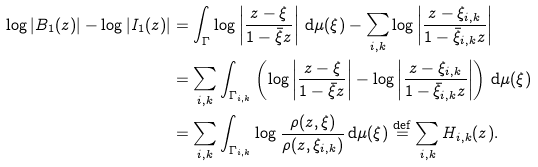<formula> <loc_0><loc_0><loc_500><loc_500>\log | B _ { 1 } ( z ) | - \log | I _ { 1 } ( z ) | & = \int _ { \Gamma } \log \left | \frac { z - \xi } { 1 - \bar { \xi } z } \right | \, \mathrm d \mu ( \xi ) - \sum _ { i , k } \log \left | \frac { z - \xi _ { i , k } } { 1 - \bar { \xi } _ { i , k } z } \right | \\ & = \sum _ { i , k } \int _ { \Gamma _ { i , k } } \left ( \log \left | \frac { z - \xi } { 1 - \bar { \xi } z } \right | - \log \left | \frac { z - \xi _ { i , k } } { 1 - \bar { \xi } _ { i , k } z } \right | \right ) \, \mathrm d \mu ( \xi ) \\ & = \sum _ { i , k } \int _ { \Gamma _ { i , k } } \log \frac { \rho ( z , \xi ) } { \rho ( z , \xi _ { i , k } ) } \, \mathrm d \mu ( \xi ) \overset { \text {def} } { = } \sum _ { i , k } H _ { i , k } ( z ) .</formula> 